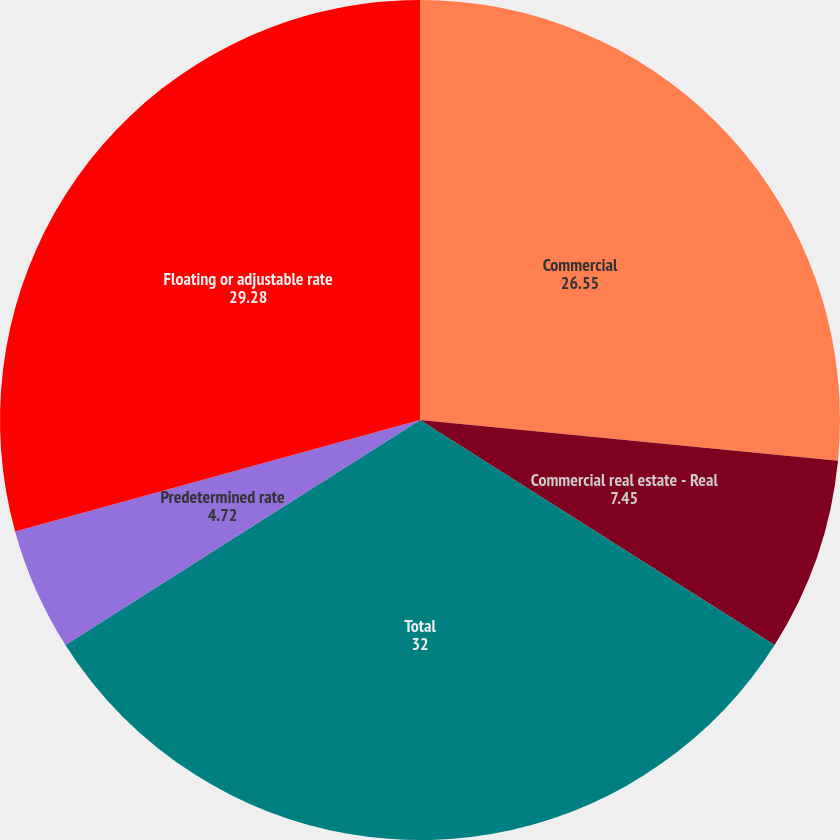Convert chart. <chart><loc_0><loc_0><loc_500><loc_500><pie_chart><fcel>Commercial<fcel>Commercial real estate - Real<fcel>Total<fcel>Predetermined rate<fcel>Floating or adjustable rate<nl><fcel>26.55%<fcel>7.45%<fcel>32.0%<fcel>4.72%<fcel>29.28%<nl></chart> 